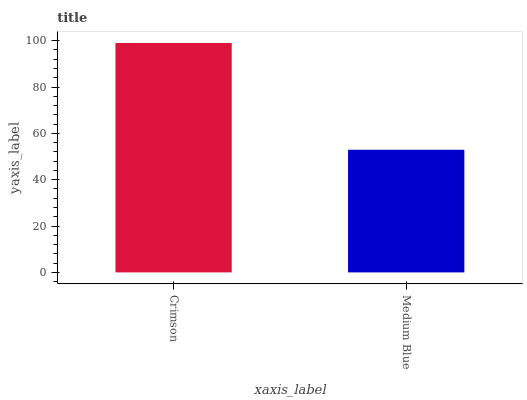Is Medium Blue the minimum?
Answer yes or no. Yes. Is Crimson the maximum?
Answer yes or no. Yes. Is Medium Blue the maximum?
Answer yes or no. No. Is Crimson greater than Medium Blue?
Answer yes or no. Yes. Is Medium Blue less than Crimson?
Answer yes or no. Yes. Is Medium Blue greater than Crimson?
Answer yes or no. No. Is Crimson less than Medium Blue?
Answer yes or no. No. Is Crimson the high median?
Answer yes or no. Yes. Is Medium Blue the low median?
Answer yes or no. Yes. Is Medium Blue the high median?
Answer yes or no. No. Is Crimson the low median?
Answer yes or no. No. 